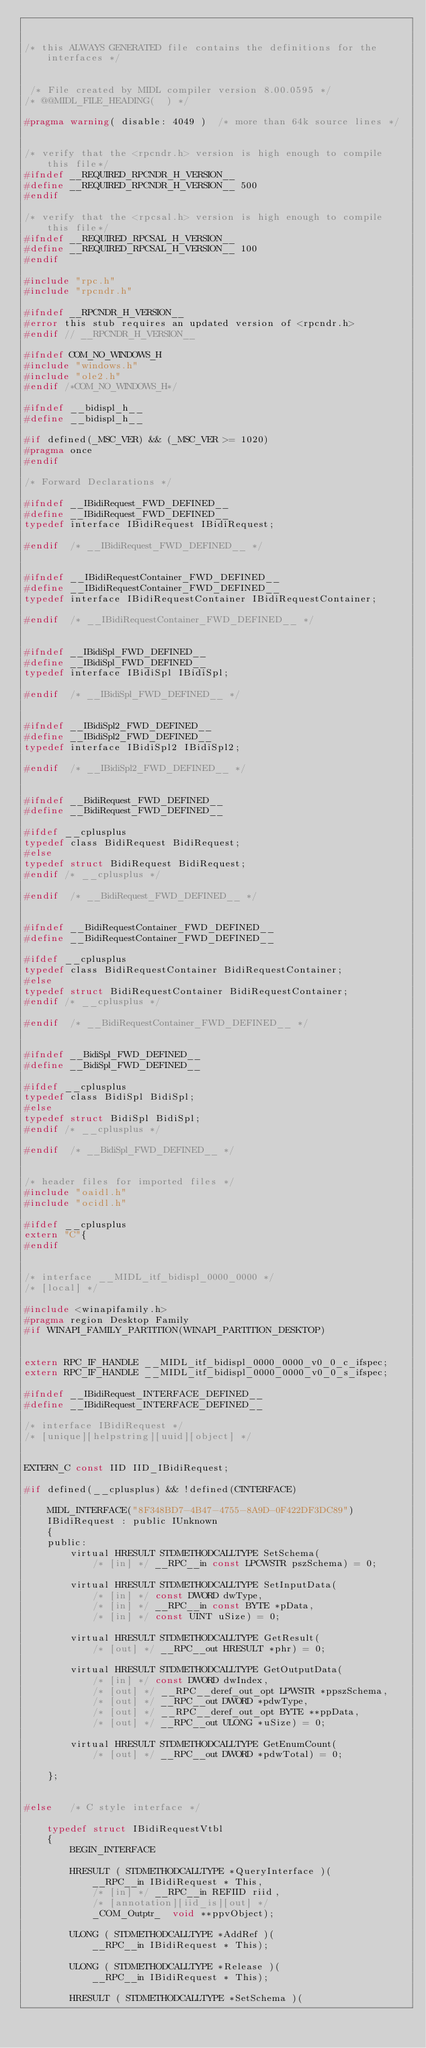Convert code to text. <code><loc_0><loc_0><loc_500><loc_500><_C_>

/* this ALWAYS GENERATED file contains the definitions for the interfaces */


 /* File created by MIDL compiler version 8.00.0595 */
/* @@MIDL_FILE_HEADING(  ) */

#pragma warning( disable: 4049 )  /* more than 64k source lines */


/* verify that the <rpcndr.h> version is high enough to compile this file*/
#ifndef __REQUIRED_RPCNDR_H_VERSION__
#define __REQUIRED_RPCNDR_H_VERSION__ 500
#endif

/* verify that the <rpcsal.h> version is high enough to compile this file*/
#ifndef __REQUIRED_RPCSAL_H_VERSION__
#define __REQUIRED_RPCSAL_H_VERSION__ 100
#endif

#include "rpc.h"
#include "rpcndr.h"

#ifndef __RPCNDR_H_VERSION__
#error this stub requires an updated version of <rpcndr.h>
#endif // __RPCNDR_H_VERSION__

#ifndef COM_NO_WINDOWS_H
#include "windows.h"
#include "ole2.h"
#endif /*COM_NO_WINDOWS_H*/

#ifndef __bidispl_h__
#define __bidispl_h__

#if defined(_MSC_VER) && (_MSC_VER >= 1020)
#pragma once
#endif

/* Forward Declarations */ 

#ifndef __IBidiRequest_FWD_DEFINED__
#define __IBidiRequest_FWD_DEFINED__
typedef interface IBidiRequest IBidiRequest;

#endif 	/* __IBidiRequest_FWD_DEFINED__ */


#ifndef __IBidiRequestContainer_FWD_DEFINED__
#define __IBidiRequestContainer_FWD_DEFINED__
typedef interface IBidiRequestContainer IBidiRequestContainer;

#endif 	/* __IBidiRequestContainer_FWD_DEFINED__ */


#ifndef __IBidiSpl_FWD_DEFINED__
#define __IBidiSpl_FWD_DEFINED__
typedef interface IBidiSpl IBidiSpl;

#endif 	/* __IBidiSpl_FWD_DEFINED__ */


#ifndef __IBidiSpl2_FWD_DEFINED__
#define __IBidiSpl2_FWD_DEFINED__
typedef interface IBidiSpl2 IBidiSpl2;

#endif 	/* __IBidiSpl2_FWD_DEFINED__ */


#ifndef __BidiRequest_FWD_DEFINED__
#define __BidiRequest_FWD_DEFINED__

#ifdef __cplusplus
typedef class BidiRequest BidiRequest;
#else
typedef struct BidiRequest BidiRequest;
#endif /* __cplusplus */

#endif 	/* __BidiRequest_FWD_DEFINED__ */


#ifndef __BidiRequestContainer_FWD_DEFINED__
#define __BidiRequestContainer_FWD_DEFINED__

#ifdef __cplusplus
typedef class BidiRequestContainer BidiRequestContainer;
#else
typedef struct BidiRequestContainer BidiRequestContainer;
#endif /* __cplusplus */

#endif 	/* __BidiRequestContainer_FWD_DEFINED__ */


#ifndef __BidiSpl_FWD_DEFINED__
#define __BidiSpl_FWD_DEFINED__

#ifdef __cplusplus
typedef class BidiSpl BidiSpl;
#else
typedef struct BidiSpl BidiSpl;
#endif /* __cplusplus */

#endif 	/* __BidiSpl_FWD_DEFINED__ */


/* header files for imported files */
#include "oaidl.h"
#include "ocidl.h"

#ifdef __cplusplus
extern "C"{
#endif 


/* interface __MIDL_itf_bidispl_0000_0000 */
/* [local] */ 

#include <winapifamily.h>
#pragma region Desktop Family
#if WINAPI_FAMILY_PARTITION(WINAPI_PARTITION_DESKTOP)


extern RPC_IF_HANDLE __MIDL_itf_bidispl_0000_0000_v0_0_c_ifspec;
extern RPC_IF_HANDLE __MIDL_itf_bidispl_0000_0000_v0_0_s_ifspec;

#ifndef __IBidiRequest_INTERFACE_DEFINED__
#define __IBidiRequest_INTERFACE_DEFINED__

/* interface IBidiRequest */
/* [unique][helpstring][uuid][object] */ 


EXTERN_C const IID IID_IBidiRequest;

#if defined(__cplusplus) && !defined(CINTERFACE)
    
    MIDL_INTERFACE("8F348BD7-4B47-4755-8A9D-0F422DF3DC89")
    IBidiRequest : public IUnknown
    {
    public:
        virtual HRESULT STDMETHODCALLTYPE SetSchema( 
            /* [in] */ __RPC__in const LPCWSTR pszSchema) = 0;
        
        virtual HRESULT STDMETHODCALLTYPE SetInputData( 
            /* [in] */ const DWORD dwType,
            /* [in] */ __RPC__in const BYTE *pData,
            /* [in] */ const UINT uSize) = 0;
        
        virtual HRESULT STDMETHODCALLTYPE GetResult( 
            /* [out] */ __RPC__out HRESULT *phr) = 0;
        
        virtual HRESULT STDMETHODCALLTYPE GetOutputData( 
            /* [in] */ const DWORD dwIndex,
            /* [out] */ __RPC__deref_out_opt LPWSTR *ppszSchema,
            /* [out] */ __RPC__out DWORD *pdwType,
            /* [out] */ __RPC__deref_out_opt BYTE **ppData,
            /* [out] */ __RPC__out ULONG *uSize) = 0;
        
        virtual HRESULT STDMETHODCALLTYPE GetEnumCount( 
            /* [out] */ __RPC__out DWORD *pdwTotal) = 0;
        
    };
    
    
#else 	/* C style interface */

    typedef struct IBidiRequestVtbl
    {
        BEGIN_INTERFACE
        
        HRESULT ( STDMETHODCALLTYPE *QueryInterface )( 
            __RPC__in IBidiRequest * This,
            /* [in] */ __RPC__in REFIID riid,
            /* [annotation][iid_is][out] */ 
            _COM_Outptr_  void **ppvObject);
        
        ULONG ( STDMETHODCALLTYPE *AddRef )( 
            __RPC__in IBidiRequest * This);
        
        ULONG ( STDMETHODCALLTYPE *Release )( 
            __RPC__in IBidiRequest * This);
        
        HRESULT ( STDMETHODCALLTYPE *SetSchema )( </code> 